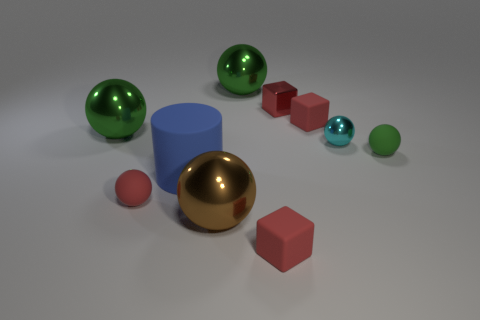How many red cubes must be subtracted to get 1 red cubes? 2 Subtract all blue blocks. How many green balls are left? 3 Subtract all brown balls. How many balls are left? 5 Subtract 1 spheres. How many spheres are left? 5 Subtract all cyan balls. How many balls are left? 5 Subtract all gray spheres. Subtract all purple cylinders. How many spheres are left? 6 Subtract all cubes. How many objects are left? 7 Add 8 green shiny balls. How many green shiny balls are left? 10 Add 4 green shiny things. How many green shiny things exist? 6 Subtract 0 brown cylinders. How many objects are left? 10 